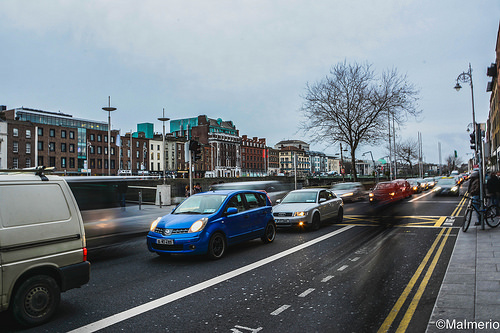<image>
Is there a sky behind the tree? Yes. From this viewpoint, the sky is positioned behind the tree, with the tree partially or fully occluding the sky. 